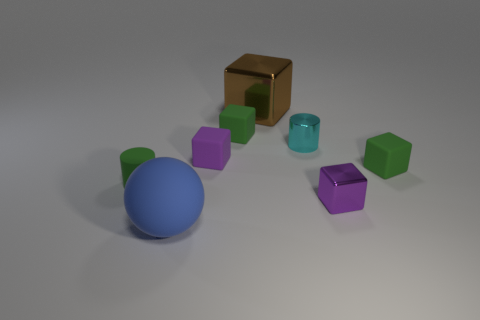How many small objects are cylinders or matte cubes?
Your answer should be very brief. 5. How many objects are either small things in front of the tiny cyan metal thing or cubes in front of the rubber cylinder?
Ensure brevity in your answer.  4. Are there fewer tiny purple rubber objects than small cyan spheres?
Offer a very short reply. No. There is a thing that is the same size as the blue rubber ball; what shape is it?
Ensure brevity in your answer.  Cube. What number of other things are the same color as the matte sphere?
Your response must be concise. 0. How many big purple rubber balls are there?
Offer a very short reply. 0. What number of tiny matte cubes are behind the cyan metal object and in front of the tiny cyan thing?
Provide a succinct answer. 0. What is the big blue sphere made of?
Make the answer very short. Rubber. Are there any cyan cylinders?
Ensure brevity in your answer.  Yes. There is a metallic cube in front of the tiny green cylinder; what is its color?
Make the answer very short. Purple. 